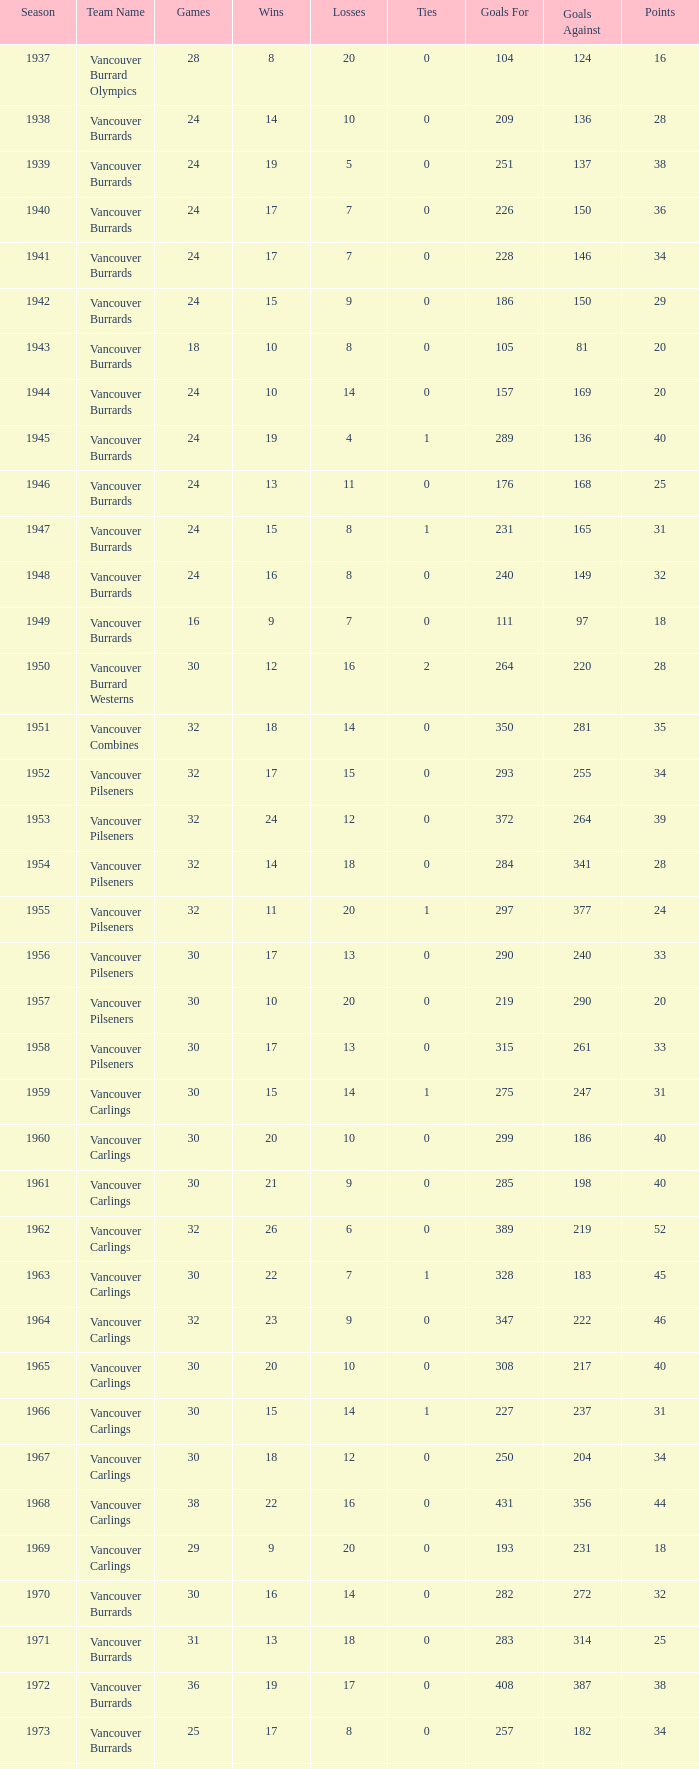What's the total number of points when the vancouver burrards have fewer than 9 losses and more than 24 games? 1.0. 